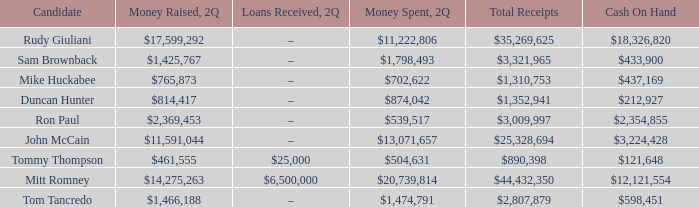Name the loans received for 2Q having total receipts of $25,328,694 –. 